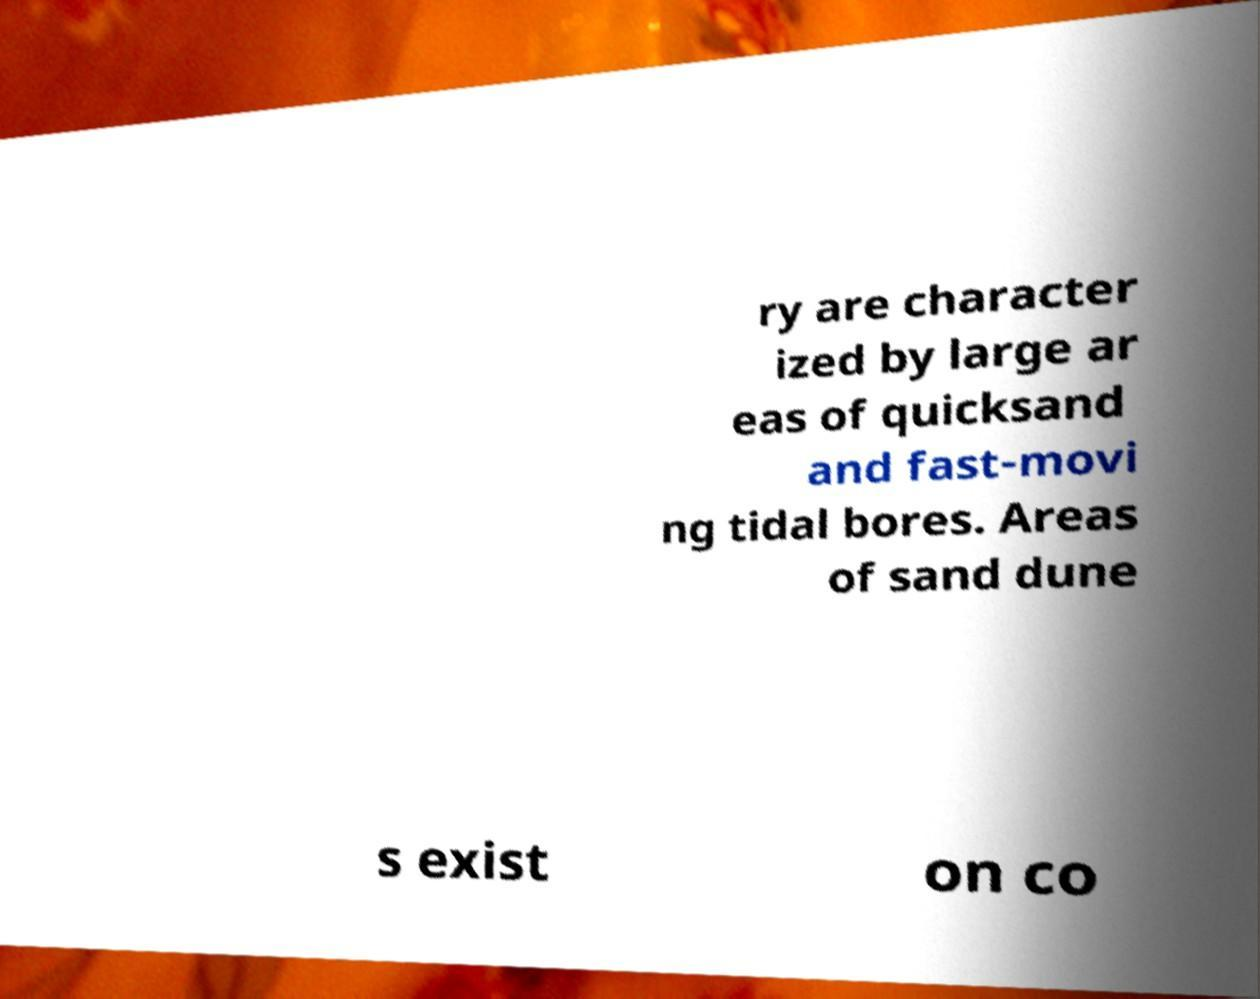Please identify and transcribe the text found in this image. ry are character ized by large ar eas of quicksand and fast-movi ng tidal bores. Areas of sand dune s exist on co 